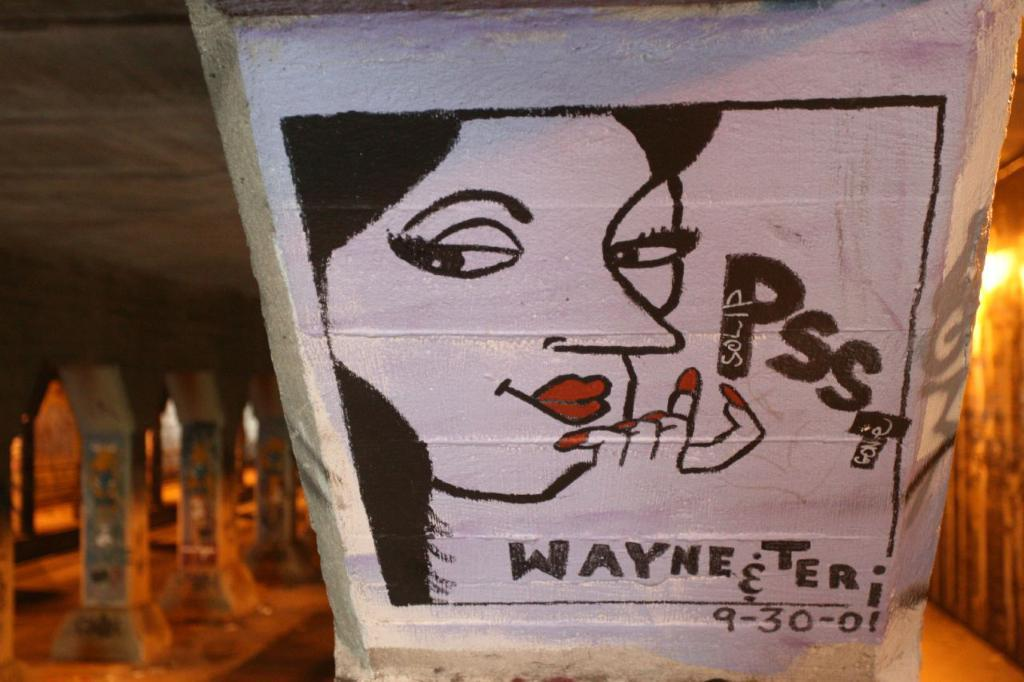What is the main subject in the foreground of the image? There is a wall painting, pillars, and a palace in the foreground of the image. What type of architectural elements are present in the foreground? There are pillars in the foreground. What type of structure is depicted in the foreground? There is a palace in the foreground. Can you describe the lighting conditions in the image? The image may have been taken during the night. How many tomatoes are placed on the palace roof in the image? There are no tomatoes present in the image. What type of toothpaste is used to paint the wall in the image? There is no toothpaste used in the image; it is a wall painting. 